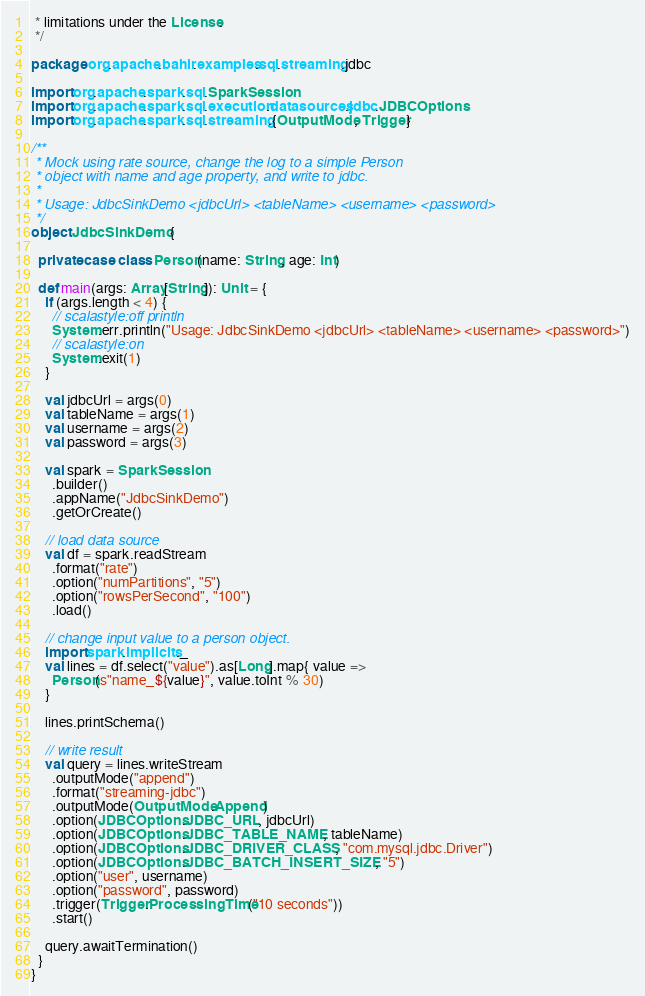Convert code to text. <code><loc_0><loc_0><loc_500><loc_500><_Scala_> * limitations under the License.
 */

package org.apache.bahir.examples.sql.streaming.jdbc

import org.apache.spark.sql.SparkSession
import org.apache.spark.sql.execution.datasources.jdbc.JDBCOptions
import org.apache.spark.sql.streaming.{OutputMode, Trigger}

/**
 * Mock using rate source, change the log to a simple Person
 * object with name and age property, and write to jdbc.
 *
 * Usage: JdbcSinkDemo <jdbcUrl> <tableName> <username> <password>
 */
object JdbcSinkDemo {

  private case class Person(name: String, age: Int)

  def main(args: Array[String]): Unit = {
    if (args.length < 4) {
      // scalastyle:off println
      System.err.println("Usage: JdbcSinkDemo <jdbcUrl> <tableName> <username> <password>")
      // scalastyle:on
      System.exit(1)
    }

    val jdbcUrl = args(0)
    val tableName = args(1)
    val username = args(2)
    val password = args(3)

    val spark = SparkSession
      .builder()
      .appName("JdbcSinkDemo")
      .getOrCreate()

    // load data source
    val df = spark.readStream
      .format("rate")
      .option("numPartitions", "5")
      .option("rowsPerSecond", "100")
      .load()

    // change input value to a person object.
    import spark.implicits._
    val lines = df.select("value").as[Long].map{ value =>
      Person(s"name_${value}", value.toInt % 30)
    }

    lines.printSchema()

    // write result
    val query = lines.writeStream
      .outputMode("append")
      .format("streaming-jdbc")
      .outputMode(OutputMode.Append)
      .option(JDBCOptions.JDBC_URL, jdbcUrl)
      .option(JDBCOptions.JDBC_TABLE_NAME, tableName)
      .option(JDBCOptions.JDBC_DRIVER_CLASS, "com.mysql.jdbc.Driver")
      .option(JDBCOptions.JDBC_BATCH_INSERT_SIZE, "5")
      .option("user", username)
      .option("password", password)
      .trigger(Trigger.ProcessingTime("10 seconds"))
      .start()

    query.awaitTermination()
  }
}
</code> 